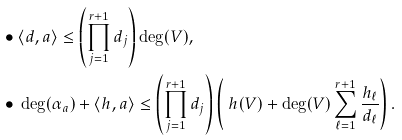<formula> <loc_0><loc_0><loc_500><loc_500>\bullet & \ \langle d , a \rangle \leq \left ( \prod _ { j = 1 } ^ { r + 1 } d _ { j } \right ) \deg ( V ) , \\ \bullet & \ \deg ( \alpha _ { a } ) + \langle h , a \rangle \leq \left ( \prod _ { j = 1 } ^ { r + 1 } d _ { j } \right ) \left ( \ h ( V ) + \deg ( V ) \sum _ { \ell = 1 } ^ { r + 1 } \frac { h _ { \ell } } { d _ { \ell } } \right ) .</formula> 